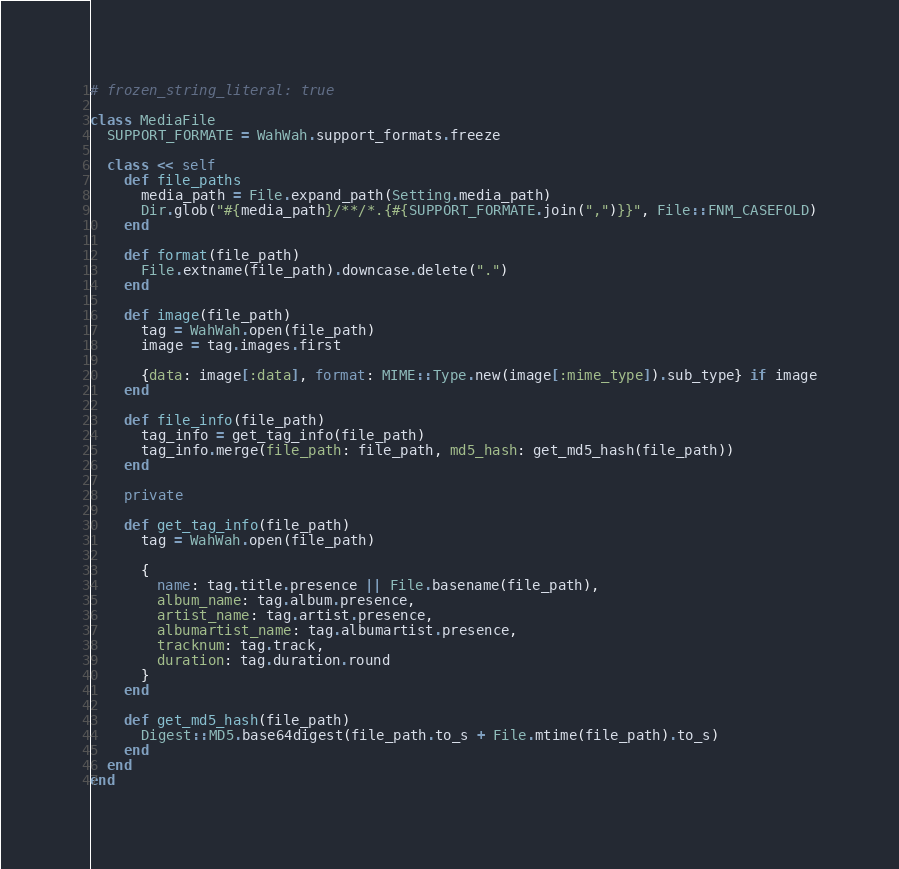<code> <loc_0><loc_0><loc_500><loc_500><_Ruby_># frozen_string_literal: true

class MediaFile
  SUPPORT_FORMATE = WahWah.support_formats.freeze

  class << self
    def file_paths
      media_path = File.expand_path(Setting.media_path)
      Dir.glob("#{media_path}/**/*.{#{SUPPORT_FORMATE.join(",")}}", File::FNM_CASEFOLD)
    end

    def format(file_path)
      File.extname(file_path).downcase.delete(".")
    end

    def image(file_path)
      tag = WahWah.open(file_path)
      image = tag.images.first

      {data: image[:data], format: MIME::Type.new(image[:mime_type]).sub_type} if image
    end

    def file_info(file_path)
      tag_info = get_tag_info(file_path)
      tag_info.merge(file_path: file_path, md5_hash: get_md5_hash(file_path))
    end

    private

    def get_tag_info(file_path)
      tag = WahWah.open(file_path)

      {
        name: tag.title.presence || File.basename(file_path),
        album_name: tag.album.presence,
        artist_name: tag.artist.presence,
        albumartist_name: tag.albumartist.presence,
        tracknum: tag.track,
        duration: tag.duration.round
      }
    end

    def get_md5_hash(file_path)
      Digest::MD5.base64digest(file_path.to_s + File.mtime(file_path).to_s)
    end
  end
end
</code> 